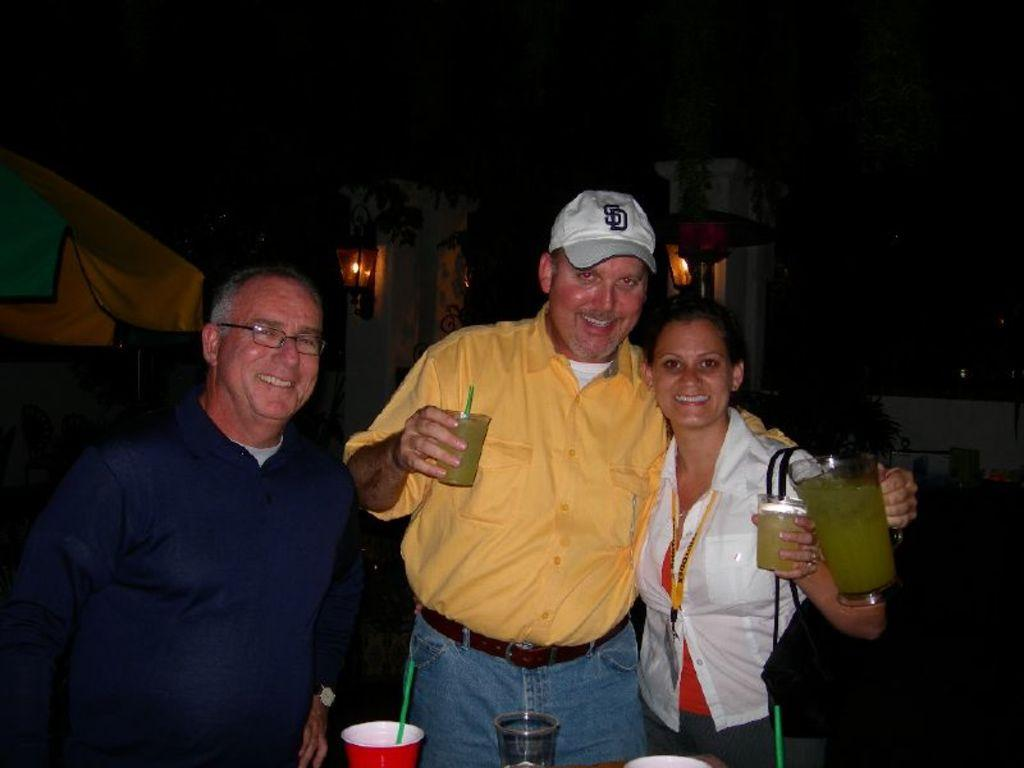<image>
Give a short and clear explanation of the subsequent image. Two men, one wearing a SD ball cap standing with a woman. 